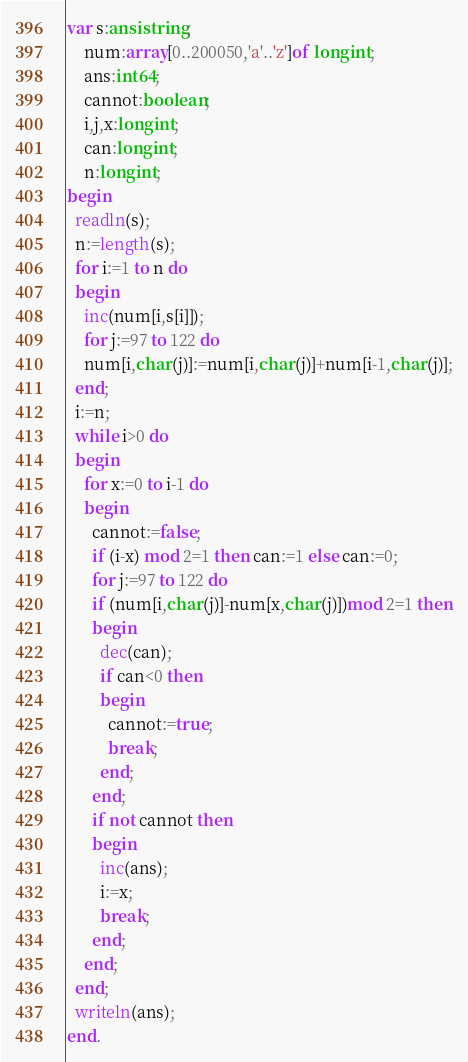Convert code to text. <code><loc_0><loc_0><loc_500><loc_500><_Pascal_>var s:ansistring;
    num:array[0..200050,'a'..'z']of longint;
    ans:int64;
    cannot:boolean;
    i,j,x:longint;
    can:longint;
    n:longint;
begin
  readln(s);
  n:=length(s);
  for i:=1 to n do
  begin
    inc(num[i,s[i]]);
    for j:=97 to 122 do
    num[i,char(j)]:=num[i,char(j)]+num[i-1,char(j)];
  end;
  i:=n;
  while i>0 do
  begin
    for x:=0 to i-1 do
    begin
      cannot:=false;
      if (i-x) mod 2=1 then can:=1 else can:=0;
      for j:=97 to 122 do
      if (num[i,char(j)]-num[x,char(j)])mod 2=1 then
      begin
        dec(can);
        if can<0 then
        begin
          cannot:=true;
          break;
        end;
      end;
      if not cannot then
      begin
        inc(ans);
        i:=x;
        break;
      end;
    end;
  end;
  writeln(ans);
end.
</code> 